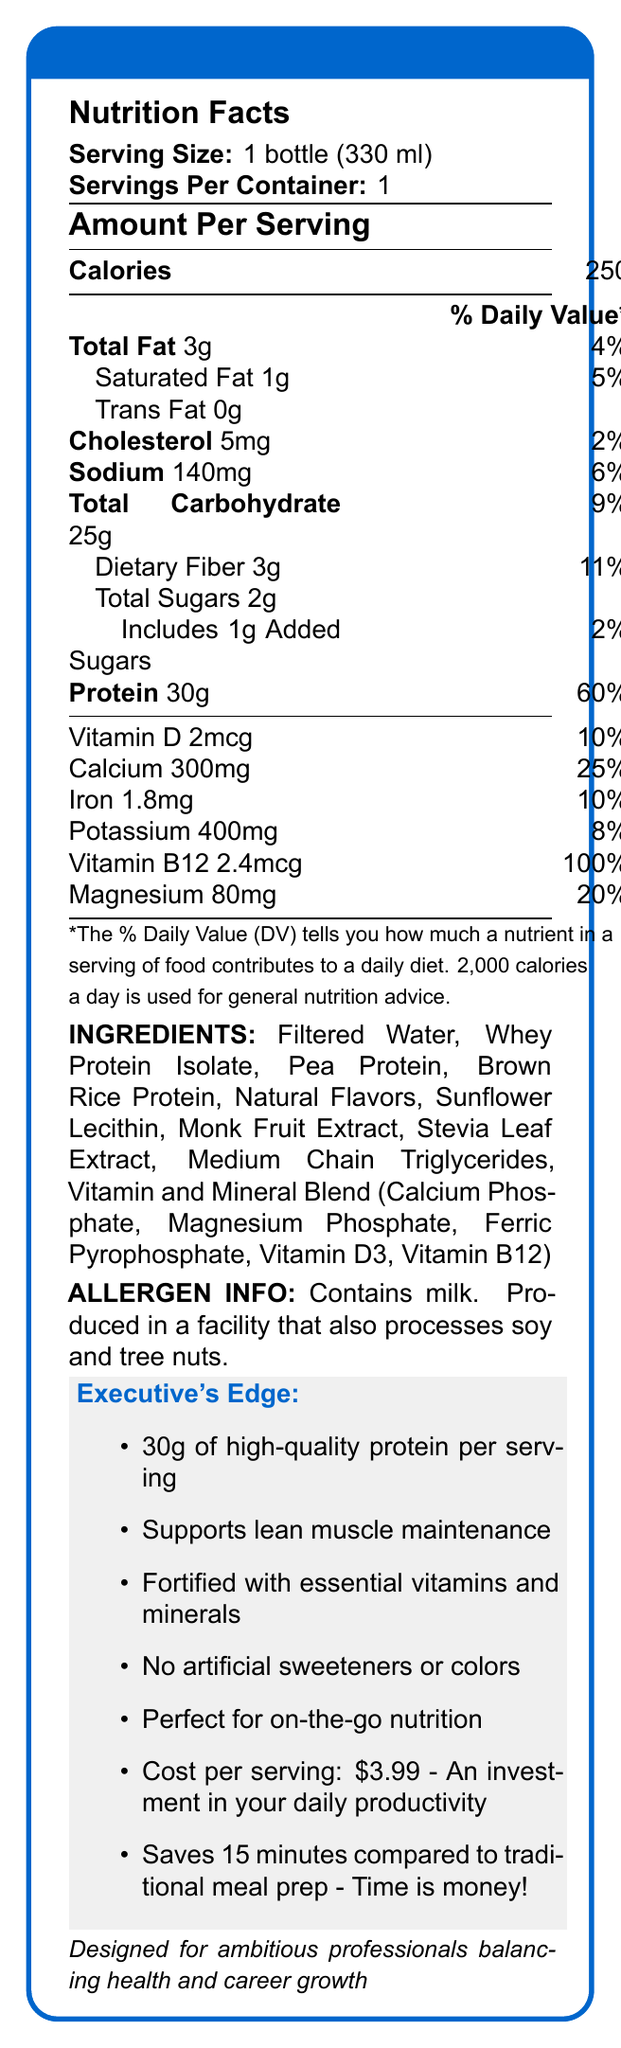What is the serving size for ExecuBoost Pro? The document states that the serving size for ExecuBoost Pro is 1 bottle (330 ml).
Answer: 1 bottle (330 ml) How many calories are there per serving of ExecuBoost Pro? The document specifies that there are 250 calories in each serving of ExecuBoost Pro.
Answer: 250 What percentage of the daily value of protein does one serving provide? The label indicates that one serving provides 60% of the daily value of protein.
Answer: 60% What is the amount of dietary fiber in one serving? According to the document, there are 3 grams of dietary fiber in one serving.
Answer: 3g How much calcium is in one serving of ExecuBoost Pro? The document states that one serving contains 300 mg of calcium.
Answer: 300mg Which ingredient is not natural in the formulation? A. Whey Protein Isolate B. Natural Flavors C. Stevia Leaf Extract D. Medium Chain Triglycerides Option D, Medium Chain Triglycerides, stands out as not being explicitly labeled as natural compared to the others listed.
Answer: D What is the main protein source in ExecuBoost Pro? The ingredients list shows that Whey Protein Isolate is the primary protein source.
Answer: Whey Protein Isolate Does ExecuBoost Pro contain any artificial sweeteners? The marketing claims specify that there are no artificial sweeteners or colors.
Answer: No Is ExecuBoost Pro suitable for individuals with nut allergies? The allergen info explicitly mentions that the product is produced in a facility that also processes tree nuts, which may pose a risk to individuals with nut allergies.
Answer: No Summarize the key benefits of ExecuBoost Pro for busy professionals. The document highlights that ExecuBoost Pro provides a substantial amount of high-quality protein, supports muscle maintenance, is fortified with important nutrients, avoids artificial additives, and offers convenience for busy professionals, hence saving them time.
Answer: ExecuBoost Pro offers 30g of high-quality protein per serving, supports lean muscle maintenance, is fortified with essential vitamins and minerals, contains no artificial sweeteners or colors, and is perfect for on-the-go nutrition. It also saves time compared to traditional meal prep. What is the cost per serving of ExecuBoost Pro? The economic efficiency section states that the cost per serving is $3.99.
Answer: $3.99 Is ExecuBoost Pro suitable for vegetarians? While the ingredients list includes plant-based proteins like pea protein and brown rice protein, it also includes whey protein isolate, which is derived from milk. Given that some vegetarians avoid all animal products, the suitability for vegetarians cannot be determined from the information provided.
Answer: Not enough information What allergens are present in ExecuBoost Pro? The document specifies that ExecuBoost Pro contains milk and is produced in a facility that also processes soy and tree nuts.
Answer: Milk What percentage of the daily value of Vitamin B12 is provided in one serving? The nutrition facts indicate that one serving provides 100% of the daily value of Vitamin B12.
Answer: 100% Which of the following minerals are included in ExecuBoost Pro? I. Sodium II. Iron III. Magnesium IV. Potassium The nutrition facts list Sodium, Iron, Magnesium, and Potassium as included minerals.
Answer: I, II, III, and IV How much time can you save by consuming ExecuBoost Pro compared to traditional meal prep? The time-saving benefit section states that consuming ExecuBoost Pro can save 15 minutes compared to traditional meal prep.
Answer: 15 minutes How many grams of total carbohydrates are there in one serving? The document specifies that there are 25 grams of total carbohydrates in one serving.
Answer: 25g 